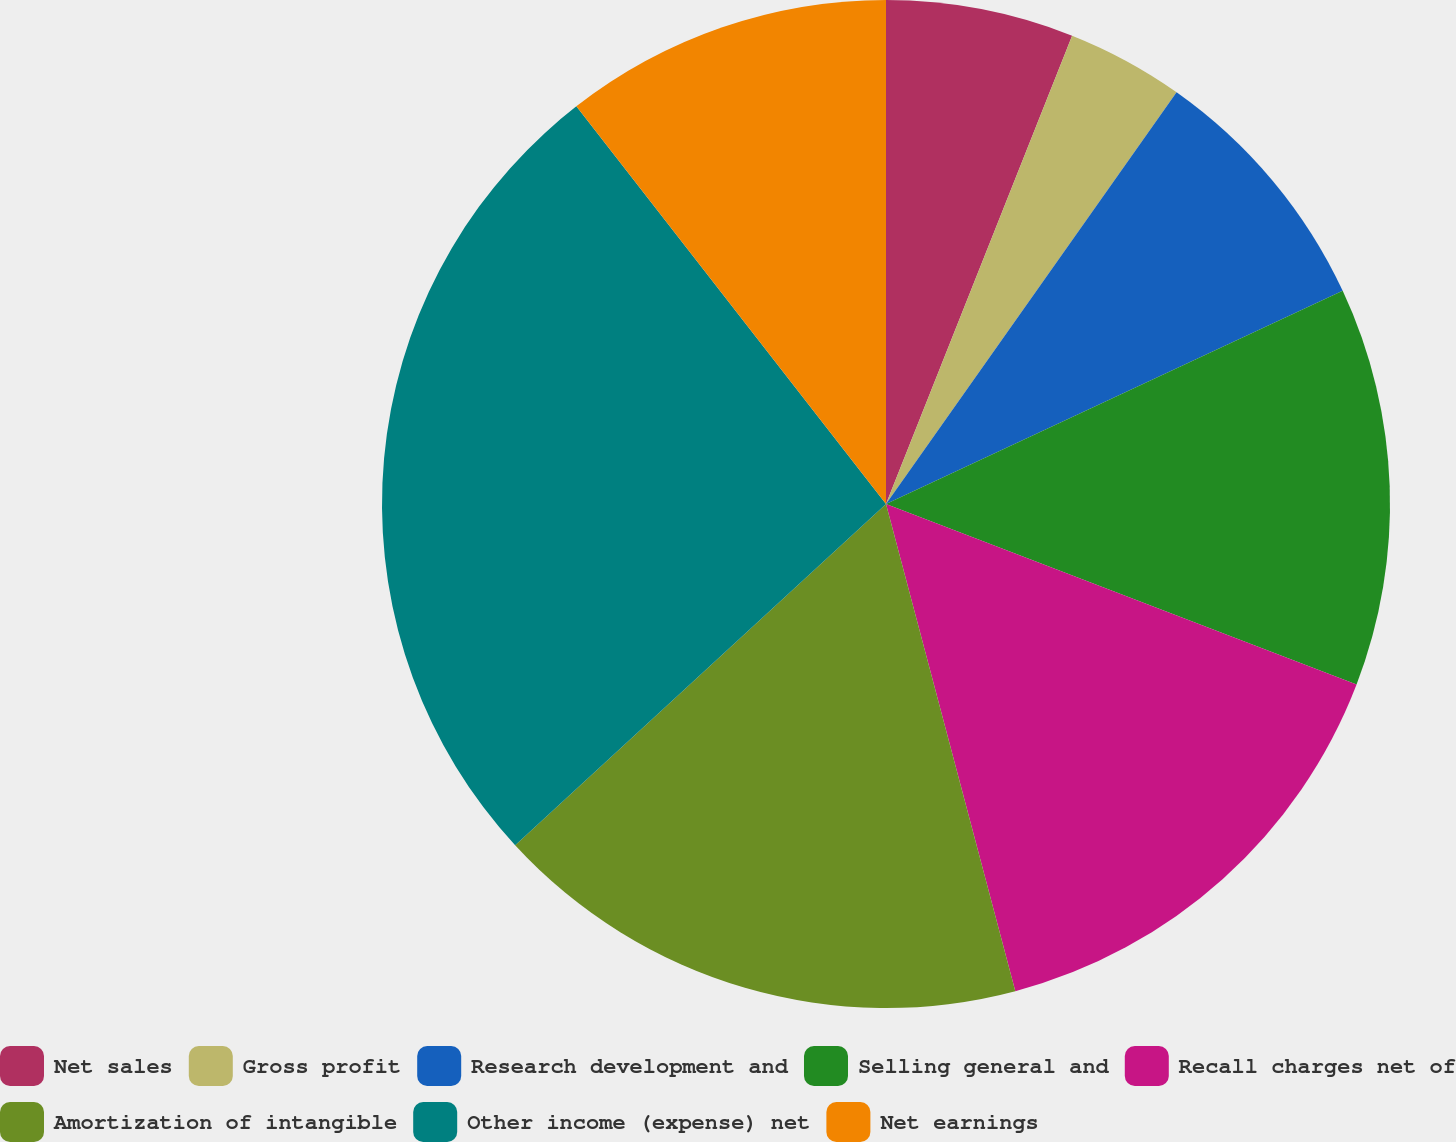Convert chart. <chart><loc_0><loc_0><loc_500><loc_500><pie_chart><fcel>Net sales<fcel>Gross profit<fcel>Research development and<fcel>Selling general and<fcel>Recall charges net of<fcel>Amortization of intangible<fcel>Other income (expense) net<fcel>Net earnings<nl><fcel>6.02%<fcel>3.76%<fcel>8.27%<fcel>12.78%<fcel>15.04%<fcel>17.29%<fcel>26.31%<fcel>10.53%<nl></chart> 